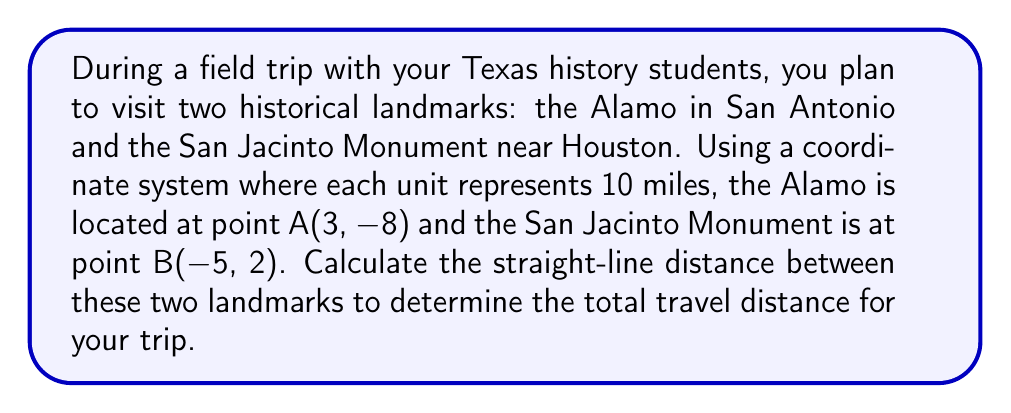Give your solution to this math problem. To calculate the distance between two points on a coordinate plane, we use the distance formula, which is derived from the Pythagorean theorem:

$$d = \sqrt{(x_2 - x_1)^2 + (y_2 - y_1)^2}$$

Where $(x_1, y_1)$ represents the coordinates of the first point and $(x_2, y_2)$ represents the coordinates of the second point.

Let's plug in our values:
- Alamo (Point A): $(x_1, y_1) = (3, -8)$
- San Jacinto Monument (Point B): $(x_2, y_2) = (-5, 2)$

Now, let's substitute these values into the formula:

$$\begin{align*}
d &= \sqrt{(-5 - 3)^2 + (2 - (-8))^2} \\
&= \sqrt{(-8)^2 + (10)^2} \\
&= \sqrt{64 + 100} \\
&= \sqrt{164} \\
&\approx 12.8062
\end{align*}$$

Remember that each unit in our coordinate system represents 10 miles. Therefore, we need to multiply our result by 10:

$$12.8062 \times 10 \approx 128.062 \text{ miles}$$

Rounding to the nearest mile, the distance is approximately 128 miles.
Answer: The straight-line distance between the Alamo and the San Jacinto Monument is approximately 128 miles. 